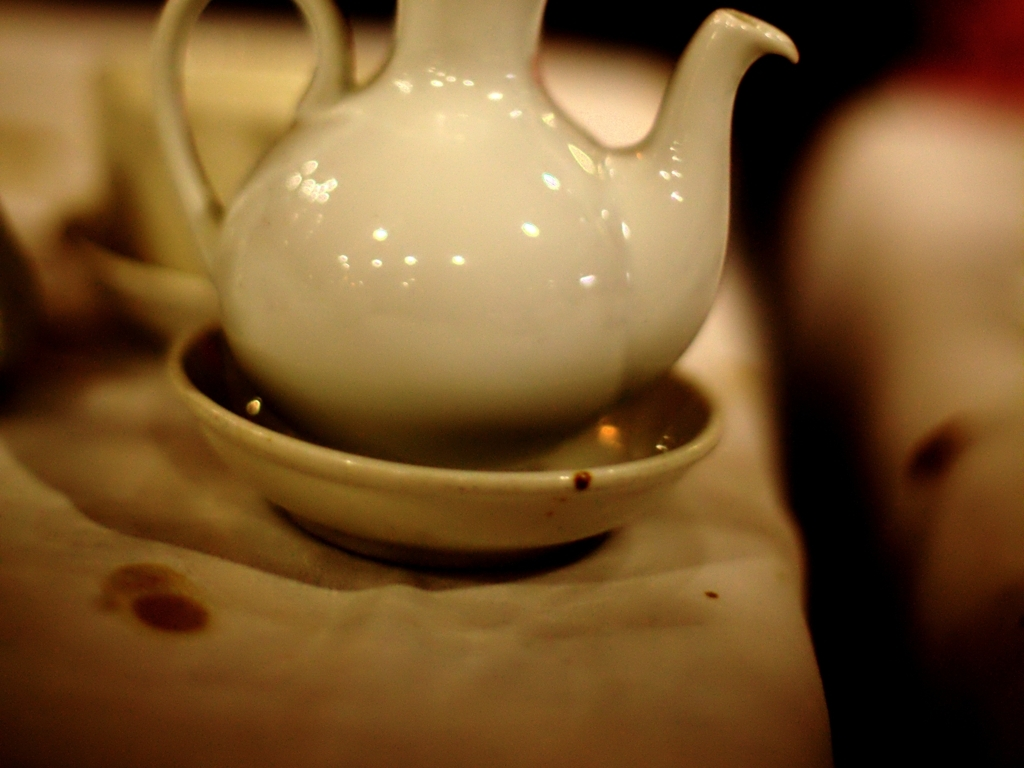What time of day do you think this photo was taken? Given the warm, subdued lighting and the presence of shadows, it suggests an indoor setting with artificial light, possibly during evening hours when such ambiance is common in settings like cafes or dinners. 